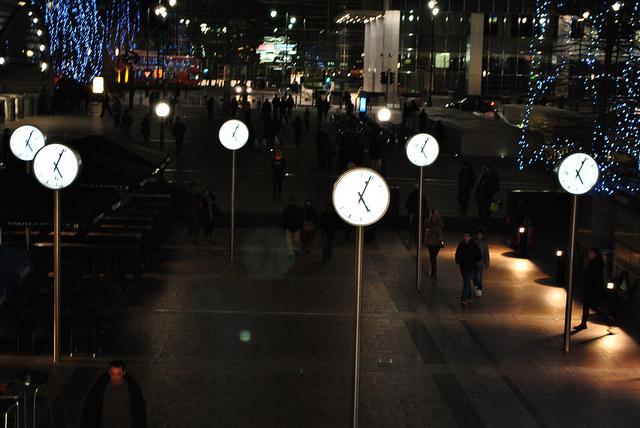How many clocks are there?
Keep it brief. 6. Are there blue lights in the tree?
Short answer required. Yes. What time is on the clocks?
Answer briefly. 5:05. 